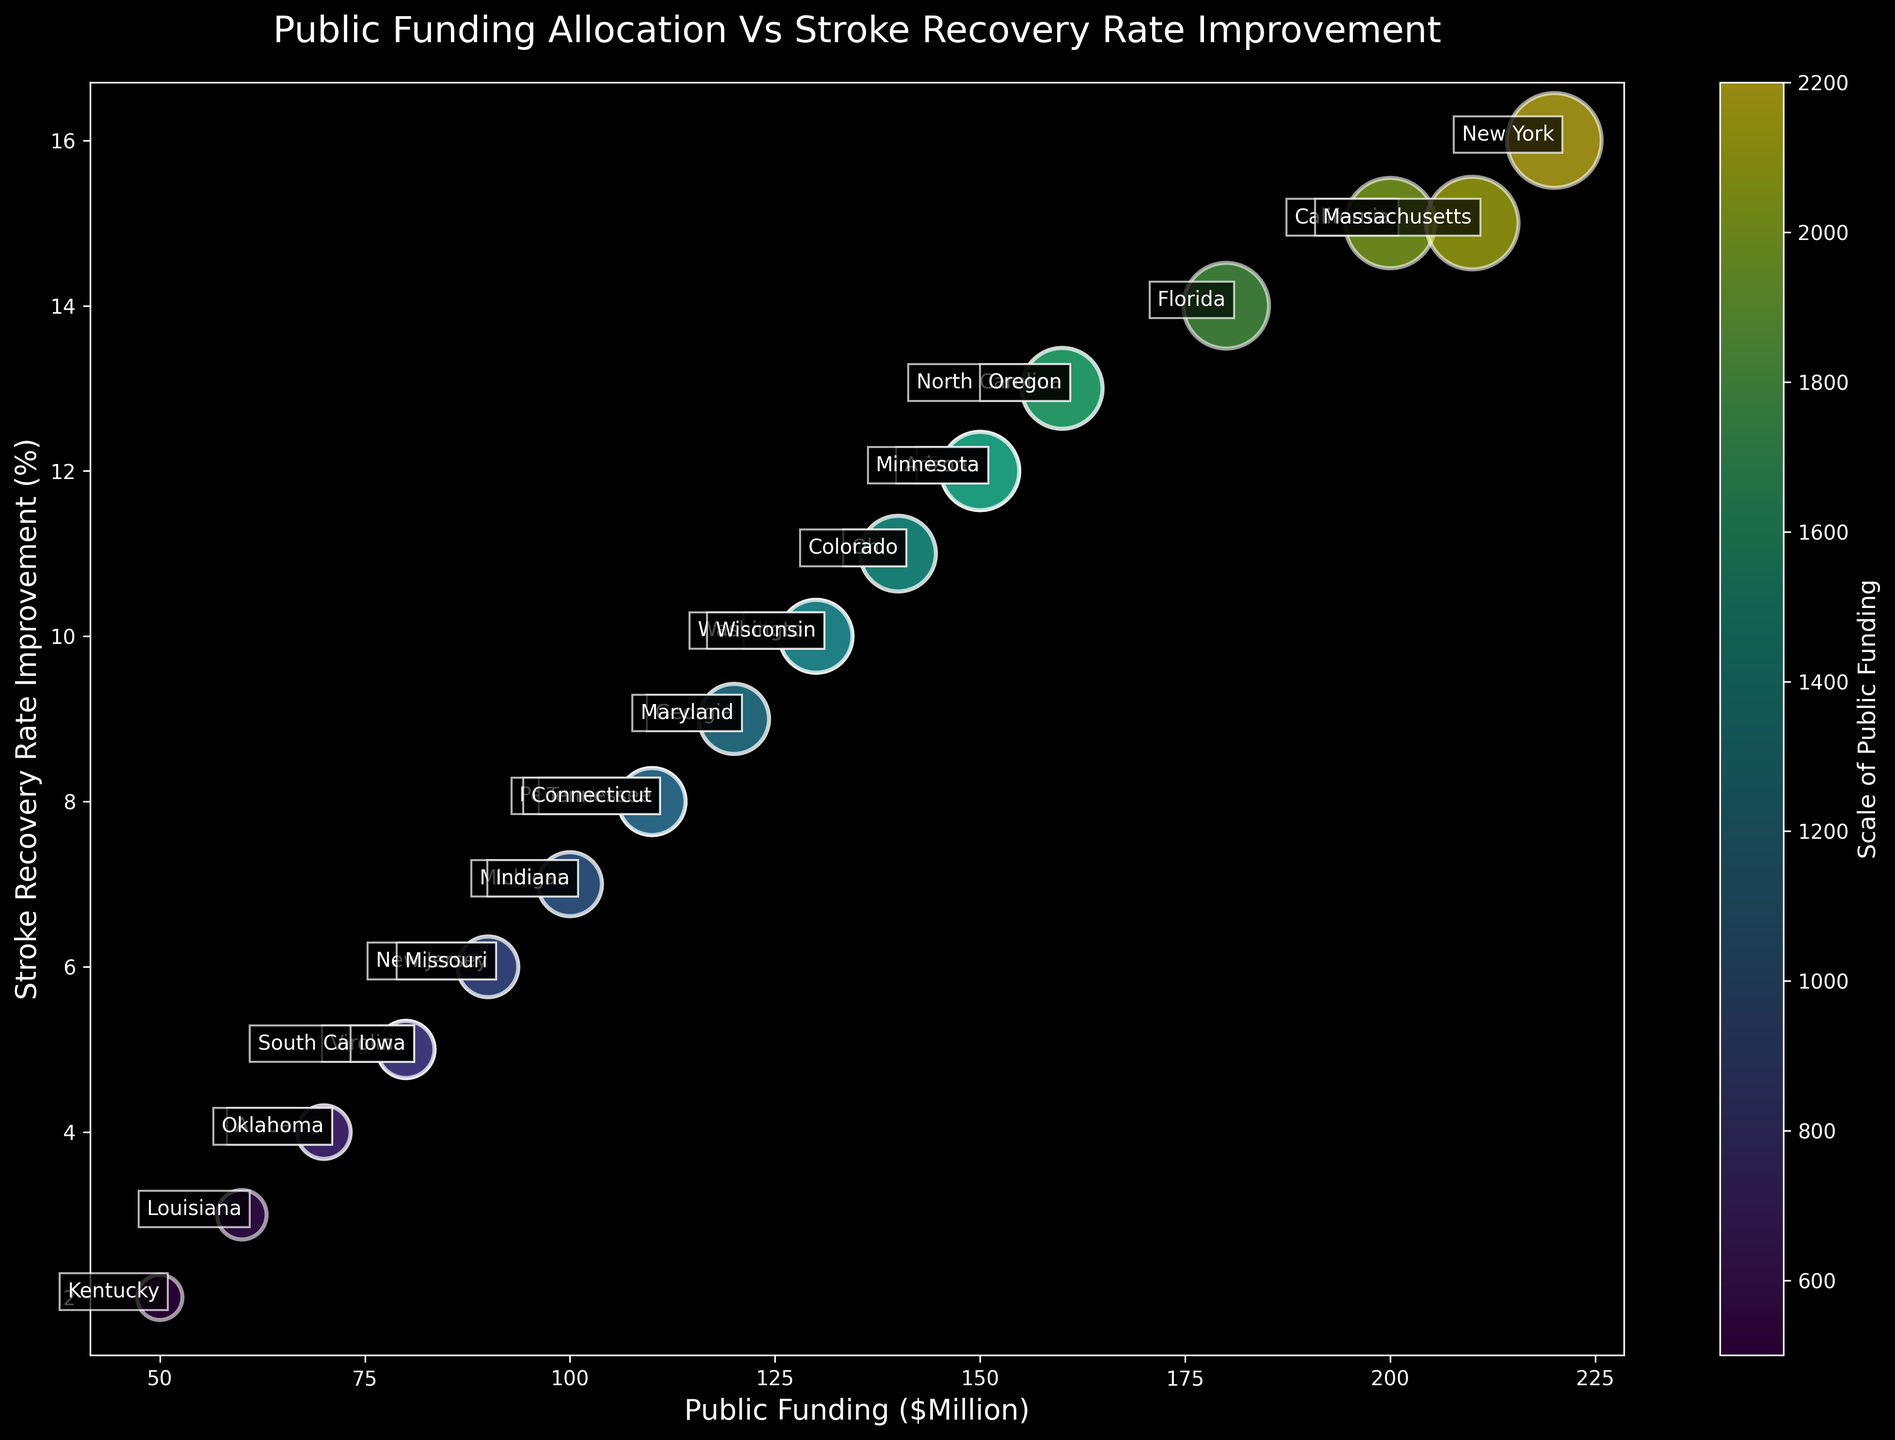What is the state with the highest public funding allocation? The state with the highest public funding allocation can be identified by looking for the largest bubble on the x-axis. New York has a funding allocation of $220 million, which is the highest.
Answer: New York How does California's stroke recovery rate improvement compare with Massachusetts'? California has a stroke recovery rate improvement of 15%, and Massachusetts also has 15%. Both states have the same rate of improvement.
Answer: Same What is the average stroke recovery rate improvement for states with public funding greater than $150 million? States with funding greater than $150 million are: California, Florida, New York, North Carolina, and Massachusetts. Their recovery rates are 15%, 14%, 16%, 13%, and 15% respectively. The average is (15 + 14 + 16 + 13 + 15) / 5 = 14.6%.
Answer: 14.6% Which states have public funding less than $100 million and a stroke recovery rate improvement higher than 5%? States with public funding less than $100 million are Michigan, New Jersey, Virginia, South Carolina, Alabama, Louisiana, Kentucky, and Iowa. Among these, Michigan and South Carolina have recovery rates higher than 5%, at 7% and 5%, respectively.
Answer: Michigan, South Carolina What is the total public funding for states with a stroke recovery rate improvement of less than 10%? States with recovery rates less than 10% are Illinois, Pennsylvania, Michigan, New Jersey, Virginia, Tennessee, Indiana, Missouri, Maryland, South Carolina, Alabama, Louisiana, Kentucky, Oklahoma, and Iowa. The total funding is 130 + 110 + 100 + 90 + 80 + 110 + 100 + 90 + 120 + 80 + 70 + 60 + 50 + 70 + 80 = $1,440 million.
Answer: $1,440 million Comparing Ohio and Georgia, which state has a higher stroke recovery rate improvement and by how much? Ohio has a stroke recovery rate improvement of 11%, and Georgia has 9%. Ohio's improvement is 2% higher than Georgia's.
Answer: Ohio by 2% What is the median public funding amount among all states? To find the median, list the funding amounts in ascending order: 50, 60, 70, 70, 80, 80, 80, 90, 90, 100, 100, 110, 110, 110, 120, 120, 130, 130, 130, 140, 140, 150, 150, 150, 160, 160, 180, 200, 210, 220. The median is the middle value, so it's (120 + 120) / 2 = $120 million.
Answer: $120 million Would boosting funding in Illinois to match Arizona improve their recovery rate by 2%? Illinois has $130 million funding with a 10% recovery rate. Arizona has $150 million funding with a 12% recovery rate. Illinois already trails Arizona by 2% at $20 million less funding. Boosting Illinois by $20 million may correlate to a 2% improvement, matching Arizona's rates. While not definitive without further data, it is a reasonable hypothesis.
Answer: Possibly How does the stroke recovery rate improvement in New Jersey compare with Virginia? New Jersey has a stroke recovery rate improvement of 6%, while Virginia has a 5% improvement. New Jersey's rate is 1% higher than Virginia's.
Answer: New Jersey by 1% Which state has the lowest stroke recovery rate improvement, and what is their funding amount? The state with the lowest stroke recovery rate improvement is Kentucky with a 2% improvement. Their funding amount is $50 million.
Answer: Kentucky with $50 million 